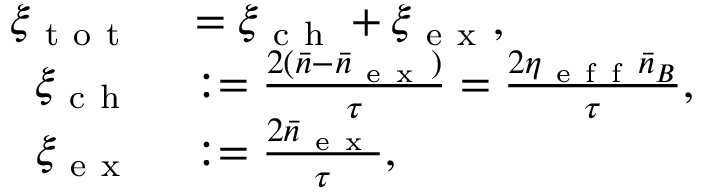Convert formula to latex. <formula><loc_0><loc_0><loc_500><loc_500>\begin{array} { r l } { \xi _ { t o t } } & = \xi _ { c h } + \xi _ { e x } , } \\ { \xi _ { c h } } & \colon = \frac { 2 ( \bar { n } - \bar { n } _ { e x } ) } { \tau } = \frac { 2 \eta _ { e f f } \bar { n } _ { B } } { \tau } , } \\ { \xi _ { e x } } & \colon = \frac { 2 \bar { n } _ { e x } } { \tau } , } \end{array}</formula> 